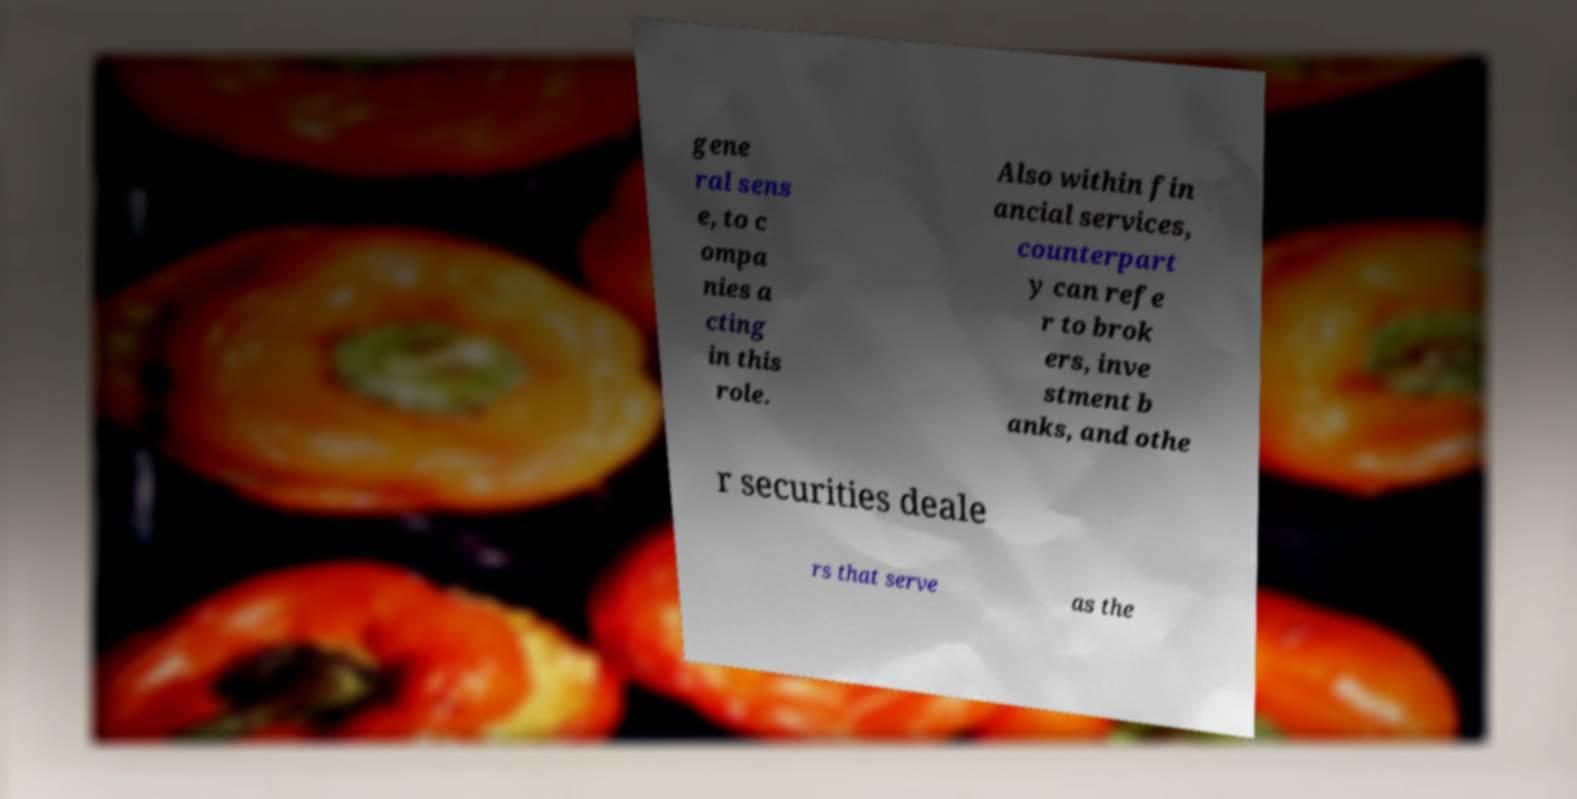Could you assist in decoding the text presented in this image and type it out clearly? gene ral sens e, to c ompa nies a cting in this role. Also within fin ancial services, counterpart y can refe r to brok ers, inve stment b anks, and othe r securities deale rs that serve as the 